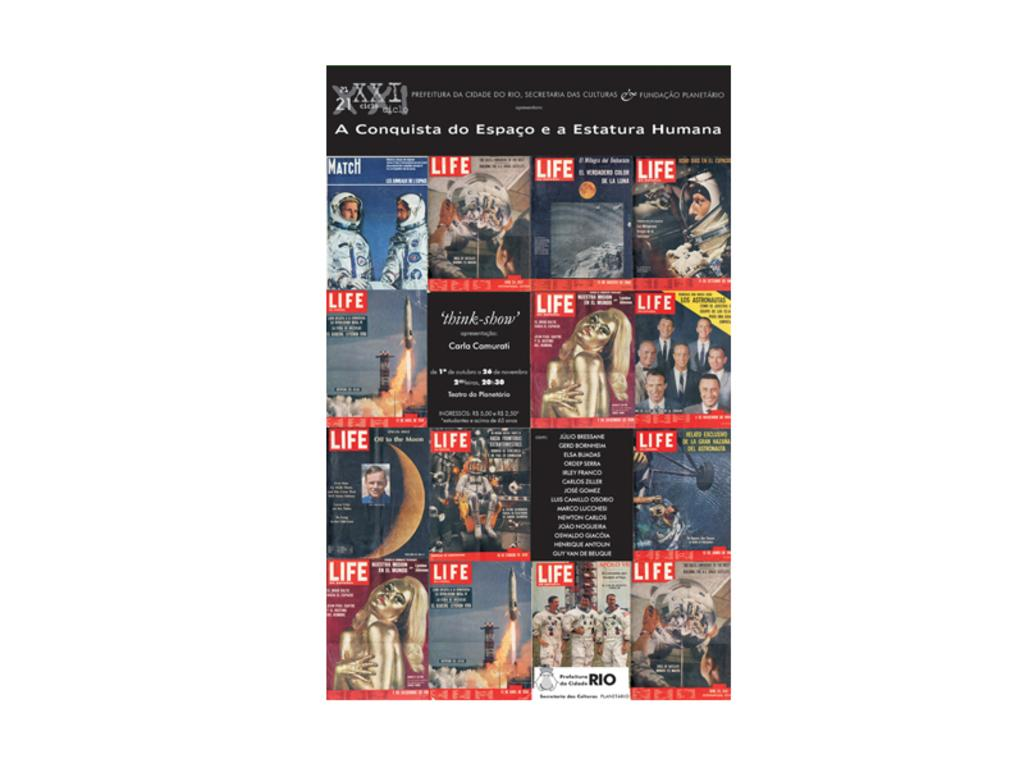Provide a one-sentence caption for the provided image. A collage of many different Life magazine covers. 